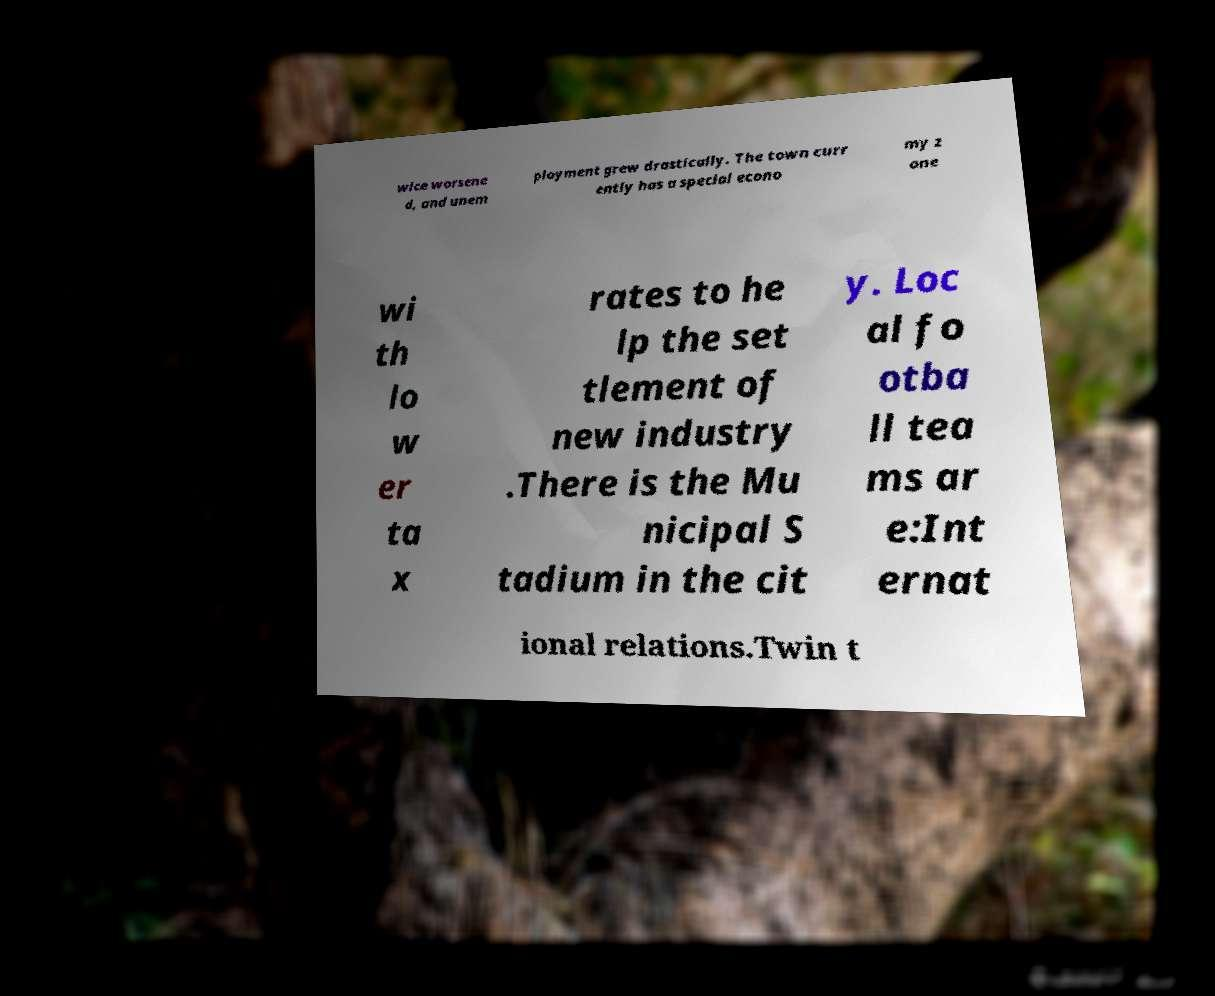Please read and relay the text visible in this image. What does it say? wice worsene d, and unem ployment grew drastically. The town curr ently has a special econo my z one wi th lo w er ta x rates to he lp the set tlement of new industry .There is the Mu nicipal S tadium in the cit y. Loc al fo otba ll tea ms ar e:Int ernat ional relations.Twin t 